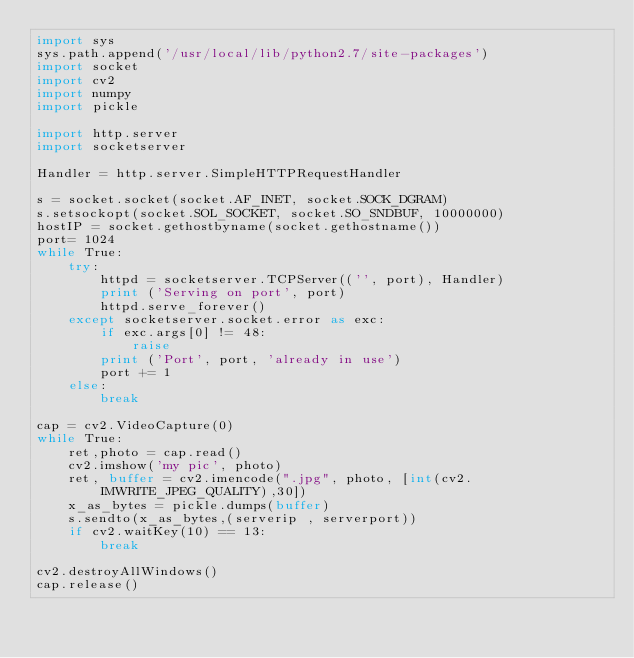<code> <loc_0><loc_0><loc_500><loc_500><_Python_>import sys
sys.path.append('/usr/local/lib/python2.7/site-packages')
import socket
import cv2
import numpy
import pickle

import http.server
import socketserver

Handler = http.server.SimpleHTTPRequestHandler

s = socket.socket(socket.AF_INET, socket.SOCK_DGRAM)
s.setsockopt(socket.SOL_SOCKET, socket.SO_SNDBUF, 10000000)
hostIP = socket.gethostbyname(socket.gethostname())
port= 1024
while True:
    try:
        httpd = socketserver.TCPServer(('', port), Handler)
        print ('Serving on port', port)
        httpd.serve_forever()
    except socketserver.socket.error as exc:
        if exc.args[0] != 48:
            raise
        print ('Port', port, 'already in use')
        port += 1
    else:
        break

cap = cv2.VideoCapture(0)
while True:
    ret,photo = cap.read()
    cv2.imshow('my pic', photo)
    ret, buffer = cv2.imencode(".jpg", photo, [int(cv2.IMWRITE_JPEG_QUALITY),30])
    x_as_bytes = pickle.dumps(buffer)
    s.sendto(x_as_bytes,(serverip , serverport))
    if cv2.waitKey(10) == 13:
        break
  
cv2.destroyAllWindows()
cap.release()


</code> 